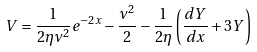<formula> <loc_0><loc_0><loc_500><loc_500>V = \frac { 1 } { 2 \eta \nu ^ { 2 } } e ^ { - 2 x } - \frac { \nu ^ { 2 } } { 2 } - \frac { 1 } { 2 \eta } \left ( \frac { d Y } { d x } + 3 Y \right )</formula> 